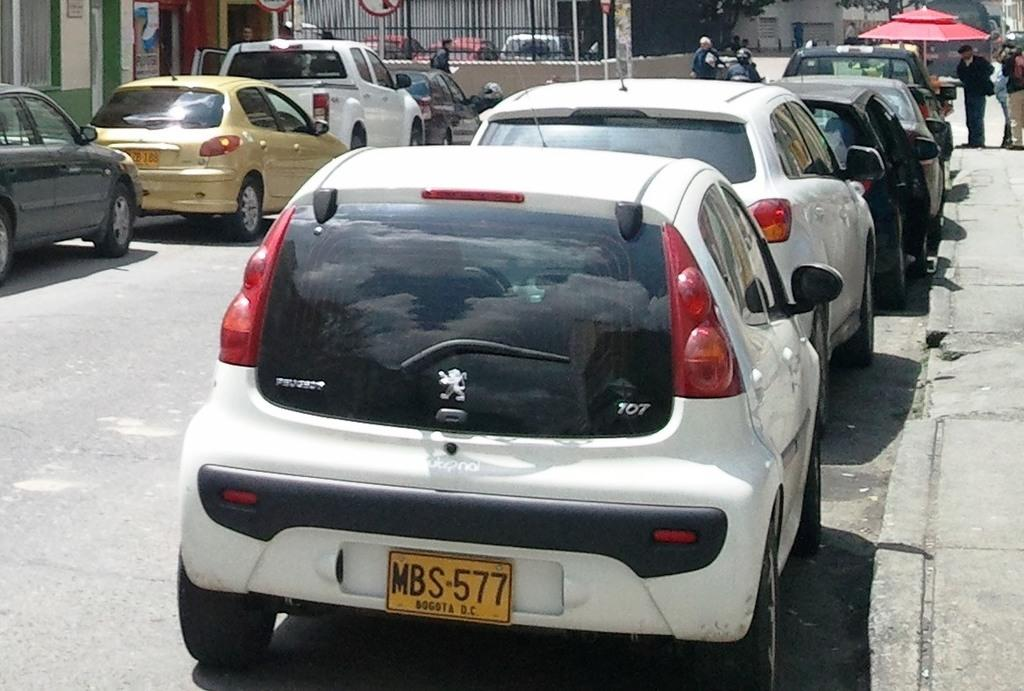What can be seen on the road in the image? There are fleets of cars on the road in the image. What type of structure is present in the image? There is an umbrella hut in the image. What is the nature of the gathering in the image? There is a crowd in the image. What is visible at the top of the image? There is a fence and trees visible at the top of the image. When was the image taken? The image was taken during the day. What type of jeans is the zebra wearing in the image? There is no zebra or jeans present in the image. What is the best route to take to reach the destination shown in the image? The image does not provide information about a specific destination or route to reach it. 